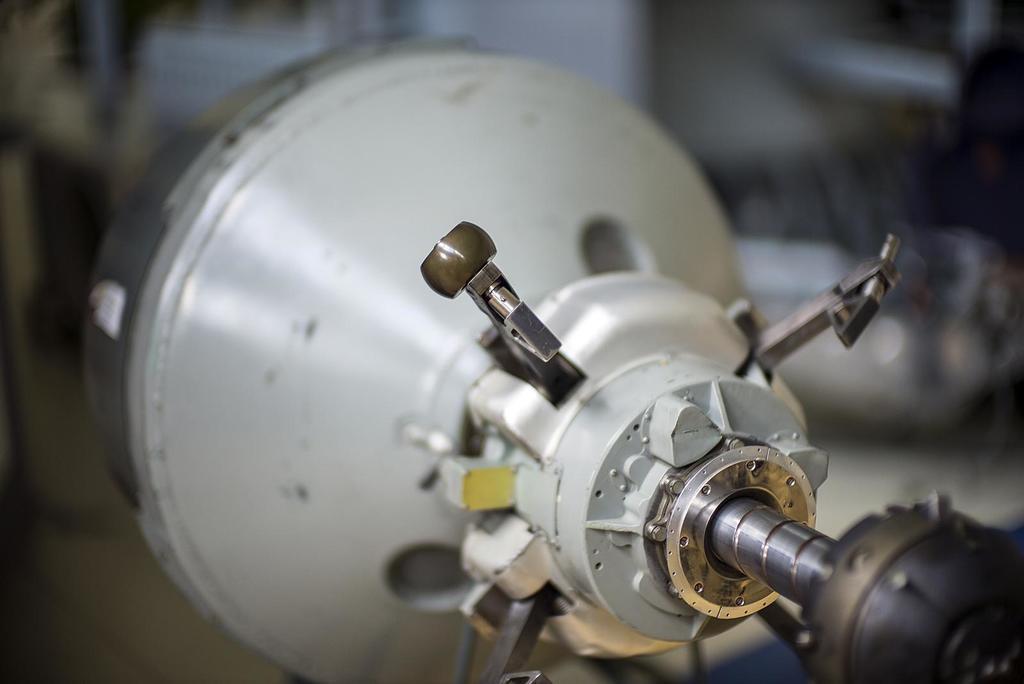How would you summarize this image in a sentence or two? In this image, It looks like an electric rotor. The background looks blurry. 